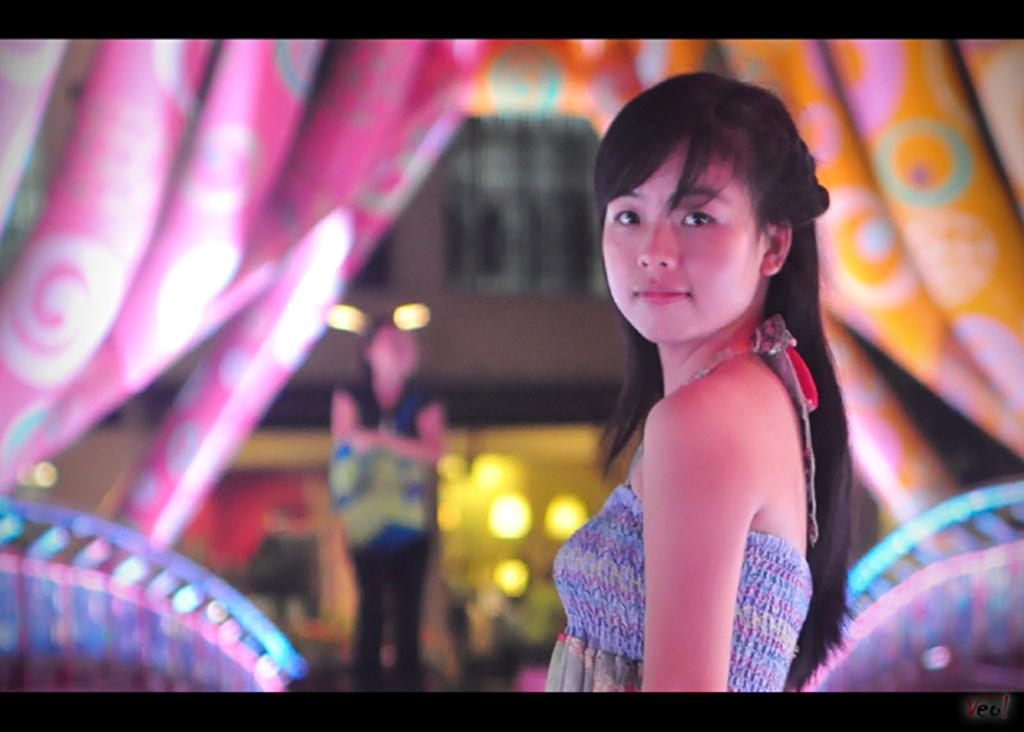Who is the main subject in the image? There is a girl in the middle of the image. What can be seen in the background of the image? There are curtains in the background of the image. When was the image taken? The image was taken at nighttime. What type of cough medicine is the girl holding in the image? There is no cough medicine or any indication of a cough in the image; the girl is simply standing in the middle of the image. 